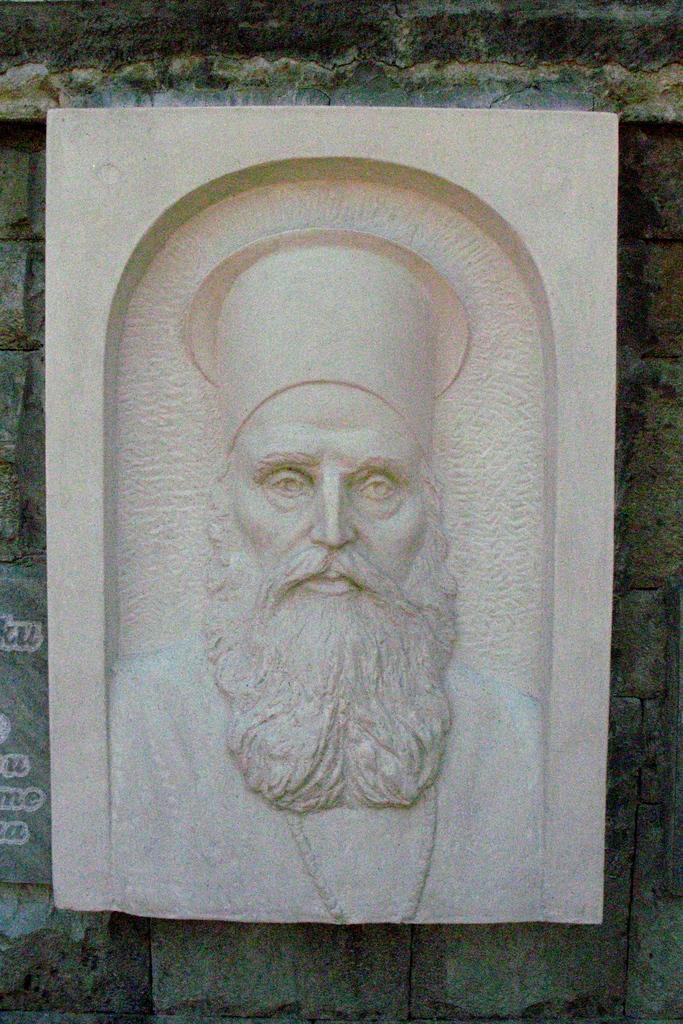Describe this image in one or two sentences. In this picture I can see there is a man´s picture engraved on the stone and he has beard, mustache and there is a chain in his neck and there is a wall in the backdrop. 